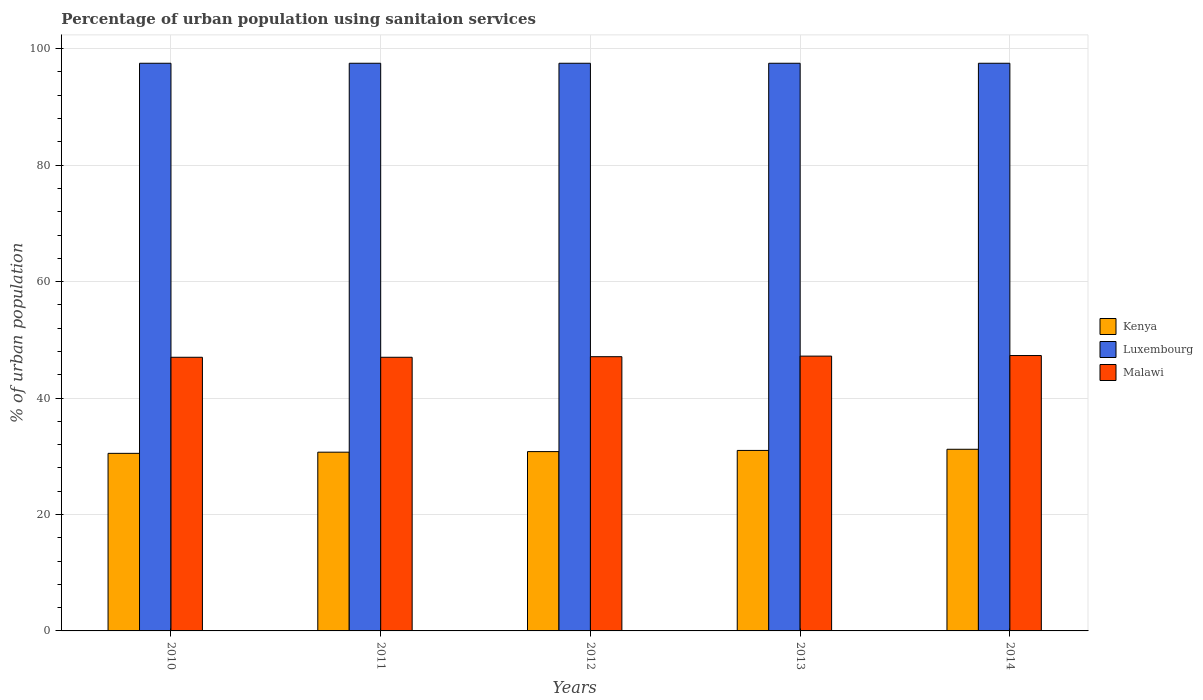How many groups of bars are there?
Ensure brevity in your answer.  5. Are the number of bars on each tick of the X-axis equal?
Ensure brevity in your answer.  Yes. How many bars are there on the 3rd tick from the left?
Keep it short and to the point. 3. What is the percentage of urban population using sanitaion services in Malawi in 2013?
Provide a succinct answer. 47.2. Across all years, what is the maximum percentage of urban population using sanitaion services in Luxembourg?
Your answer should be compact. 97.5. Across all years, what is the minimum percentage of urban population using sanitaion services in Luxembourg?
Keep it short and to the point. 97.5. In which year was the percentage of urban population using sanitaion services in Luxembourg maximum?
Provide a short and direct response. 2010. In which year was the percentage of urban population using sanitaion services in Luxembourg minimum?
Your answer should be very brief. 2010. What is the total percentage of urban population using sanitaion services in Kenya in the graph?
Keep it short and to the point. 154.2. What is the difference between the percentage of urban population using sanitaion services in Luxembourg in 2010 and that in 2013?
Give a very brief answer. 0. What is the difference between the percentage of urban population using sanitaion services in Kenya in 2010 and the percentage of urban population using sanitaion services in Luxembourg in 2013?
Your response must be concise. -67. What is the average percentage of urban population using sanitaion services in Luxembourg per year?
Your answer should be very brief. 97.5. In the year 2014, what is the difference between the percentage of urban population using sanitaion services in Malawi and percentage of urban population using sanitaion services in Luxembourg?
Provide a succinct answer. -50.2. What is the ratio of the percentage of urban population using sanitaion services in Kenya in 2011 to that in 2014?
Make the answer very short. 0.98. Is the percentage of urban population using sanitaion services in Malawi in 2013 less than that in 2014?
Provide a succinct answer. Yes. Is the difference between the percentage of urban population using sanitaion services in Malawi in 2011 and 2014 greater than the difference between the percentage of urban population using sanitaion services in Luxembourg in 2011 and 2014?
Give a very brief answer. No. What is the difference between the highest and the second highest percentage of urban population using sanitaion services in Luxembourg?
Your answer should be very brief. 0. What does the 1st bar from the left in 2011 represents?
Offer a terse response. Kenya. What does the 1st bar from the right in 2012 represents?
Ensure brevity in your answer.  Malawi. Is it the case that in every year, the sum of the percentage of urban population using sanitaion services in Luxembourg and percentage of urban population using sanitaion services in Kenya is greater than the percentage of urban population using sanitaion services in Malawi?
Offer a terse response. Yes. Are all the bars in the graph horizontal?
Provide a short and direct response. No. How many years are there in the graph?
Make the answer very short. 5. Does the graph contain any zero values?
Offer a terse response. No. Does the graph contain grids?
Offer a very short reply. Yes. How many legend labels are there?
Give a very brief answer. 3. How are the legend labels stacked?
Keep it short and to the point. Vertical. What is the title of the graph?
Give a very brief answer. Percentage of urban population using sanitaion services. What is the label or title of the X-axis?
Provide a succinct answer. Years. What is the label or title of the Y-axis?
Keep it short and to the point. % of urban population. What is the % of urban population of Kenya in 2010?
Keep it short and to the point. 30.5. What is the % of urban population of Luxembourg in 2010?
Keep it short and to the point. 97.5. What is the % of urban population in Kenya in 2011?
Give a very brief answer. 30.7. What is the % of urban population of Luxembourg in 2011?
Make the answer very short. 97.5. What is the % of urban population in Kenya in 2012?
Provide a short and direct response. 30.8. What is the % of urban population in Luxembourg in 2012?
Provide a short and direct response. 97.5. What is the % of urban population in Malawi in 2012?
Your response must be concise. 47.1. What is the % of urban population in Kenya in 2013?
Offer a terse response. 31. What is the % of urban population of Luxembourg in 2013?
Your response must be concise. 97.5. What is the % of urban population in Malawi in 2013?
Your response must be concise. 47.2. What is the % of urban population of Kenya in 2014?
Keep it short and to the point. 31.2. What is the % of urban population of Luxembourg in 2014?
Your answer should be very brief. 97.5. What is the % of urban population in Malawi in 2014?
Give a very brief answer. 47.3. Across all years, what is the maximum % of urban population in Kenya?
Offer a very short reply. 31.2. Across all years, what is the maximum % of urban population of Luxembourg?
Make the answer very short. 97.5. Across all years, what is the maximum % of urban population of Malawi?
Keep it short and to the point. 47.3. Across all years, what is the minimum % of urban population in Kenya?
Ensure brevity in your answer.  30.5. Across all years, what is the minimum % of urban population of Luxembourg?
Provide a short and direct response. 97.5. What is the total % of urban population in Kenya in the graph?
Provide a succinct answer. 154.2. What is the total % of urban population of Luxembourg in the graph?
Provide a succinct answer. 487.5. What is the total % of urban population in Malawi in the graph?
Offer a terse response. 235.6. What is the difference between the % of urban population in Kenya in 2010 and that in 2012?
Your response must be concise. -0.3. What is the difference between the % of urban population of Kenya in 2010 and that in 2013?
Offer a terse response. -0.5. What is the difference between the % of urban population of Kenya in 2010 and that in 2014?
Give a very brief answer. -0.7. What is the difference between the % of urban population in Luxembourg in 2010 and that in 2014?
Provide a short and direct response. 0. What is the difference between the % of urban population of Kenya in 2011 and that in 2012?
Make the answer very short. -0.1. What is the difference between the % of urban population of Luxembourg in 2011 and that in 2012?
Your answer should be compact. 0. What is the difference between the % of urban population of Luxembourg in 2011 and that in 2013?
Provide a short and direct response. 0. What is the difference between the % of urban population in Malawi in 2011 and that in 2013?
Make the answer very short. -0.2. What is the difference between the % of urban population in Malawi in 2011 and that in 2014?
Provide a succinct answer. -0.3. What is the difference between the % of urban population of Luxembourg in 2012 and that in 2013?
Offer a terse response. 0. What is the difference between the % of urban population of Malawi in 2012 and that in 2013?
Give a very brief answer. -0.1. What is the difference between the % of urban population of Luxembourg in 2012 and that in 2014?
Offer a terse response. 0. What is the difference between the % of urban population in Kenya in 2013 and that in 2014?
Ensure brevity in your answer.  -0.2. What is the difference between the % of urban population of Malawi in 2013 and that in 2014?
Your answer should be compact. -0.1. What is the difference between the % of urban population of Kenya in 2010 and the % of urban population of Luxembourg in 2011?
Your answer should be very brief. -67. What is the difference between the % of urban population in Kenya in 2010 and the % of urban population in Malawi in 2011?
Offer a very short reply. -16.5. What is the difference between the % of urban population in Luxembourg in 2010 and the % of urban population in Malawi in 2011?
Your answer should be compact. 50.5. What is the difference between the % of urban population of Kenya in 2010 and the % of urban population of Luxembourg in 2012?
Provide a succinct answer. -67. What is the difference between the % of urban population in Kenya in 2010 and the % of urban population in Malawi in 2012?
Offer a very short reply. -16.6. What is the difference between the % of urban population in Luxembourg in 2010 and the % of urban population in Malawi in 2012?
Provide a succinct answer. 50.4. What is the difference between the % of urban population in Kenya in 2010 and the % of urban population in Luxembourg in 2013?
Offer a terse response. -67. What is the difference between the % of urban population of Kenya in 2010 and the % of urban population of Malawi in 2013?
Your answer should be very brief. -16.7. What is the difference between the % of urban population in Luxembourg in 2010 and the % of urban population in Malawi in 2013?
Offer a very short reply. 50.3. What is the difference between the % of urban population of Kenya in 2010 and the % of urban population of Luxembourg in 2014?
Your response must be concise. -67. What is the difference between the % of urban population in Kenya in 2010 and the % of urban population in Malawi in 2014?
Provide a short and direct response. -16.8. What is the difference between the % of urban population of Luxembourg in 2010 and the % of urban population of Malawi in 2014?
Make the answer very short. 50.2. What is the difference between the % of urban population of Kenya in 2011 and the % of urban population of Luxembourg in 2012?
Provide a succinct answer. -66.8. What is the difference between the % of urban population in Kenya in 2011 and the % of urban population in Malawi in 2012?
Keep it short and to the point. -16.4. What is the difference between the % of urban population of Luxembourg in 2011 and the % of urban population of Malawi in 2012?
Your answer should be very brief. 50.4. What is the difference between the % of urban population of Kenya in 2011 and the % of urban population of Luxembourg in 2013?
Make the answer very short. -66.8. What is the difference between the % of urban population of Kenya in 2011 and the % of urban population of Malawi in 2013?
Offer a very short reply. -16.5. What is the difference between the % of urban population in Luxembourg in 2011 and the % of urban population in Malawi in 2013?
Make the answer very short. 50.3. What is the difference between the % of urban population of Kenya in 2011 and the % of urban population of Luxembourg in 2014?
Give a very brief answer. -66.8. What is the difference between the % of urban population in Kenya in 2011 and the % of urban population in Malawi in 2014?
Your answer should be compact. -16.6. What is the difference between the % of urban population of Luxembourg in 2011 and the % of urban population of Malawi in 2014?
Your answer should be compact. 50.2. What is the difference between the % of urban population in Kenya in 2012 and the % of urban population in Luxembourg in 2013?
Provide a succinct answer. -66.7. What is the difference between the % of urban population in Kenya in 2012 and the % of urban population in Malawi in 2013?
Offer a terse response. -16.4. What is the difference between the % of urban population in Luxembourg in 2012 and the % of urban population in Malawi in 2013?
Give a very brief answer. 50.3. What is the difference between the % of urban population of Kenya in 2012 and the % of urban population of Luxembourg in 2014?
Make the answer very short. -66.7. What is the difference between the % of urban population of Kenya in 2012 and the % of urban population of Malawi in 2014?
Give a very brief answer. -16.5. What is the difference between the % of urban population in Luxembourg in 2012 and the % of urban population in Malawi in 2014?
Your response must be concise. 50.2. What is the difference between the % of urban population in Kenya in 2013 and the % of urban population in Luxembourg in 2014?
Provide a succinct answer. -66.5. What is the difference between the % of urban population of Kenya in 2013 and the % of urban population of Malawi in 2014?
Your response must be concise. -16.3. What is the difference between the % of urban population of Luxembourg in 2013 and the % of urban population of Malawi in 2014?
Give a very brief answer. 50.2. What is the average % of urban population in Kenya per year?
Offer a terse response. 30.84. What is the average % of urban population in Luxembourg per year?
Offer a terse response. 97.5. What is the average % of urban population in Malawi per year?
Your response must be concise. 47.12. In the year 2010, what is the difference between the % of urban population in Kenya and % of urban population in Luxembourg?
Give a very brief answer. -67. In the year 2010, what is the difference between the % of urban population in Kenya and % of urban population in Malawi?
Make the answer very short. -16.5. In the year 2010, what is the difference between the % of urban population of Luxembourg and % of urban population of Malawi?
Your answer should be compact. 50.5. In the year 2011, what is the difference between the % of urban population of Kenya and % of urban population of Luxembourg?
Your response must be concise. -66.8. In the year 2011, what is the difference between the % of urban population in Kenya and % of urban population in Malawi?
Provide a succinct answer. -16.3. In the year 2011, what is the difference between the % of urban population of Luxembourg and % of urban population of Malawi?
Your answer should be very brief. 50.5. In the year 2012, what is the difference between the % of urban population in Kenya and % of urban population in Luxembourg?
Make the answer very short. -66.7. In the year 2012, what is the difference between the % of urban population in Kenya and % of urban population in Malawi?
Make the answer very short. -16.3. In the year 2012, what is the difference between the % of urban population in Luxembourg and % of urban population in Malawi?
Your answer should be compact. 50.4. In the year 2013, what is the difference between the % of urban population of Kenya and % of urban population of Luxembourg?
Provide a succinct answer. -66.5. In the year 2013, what is the difference between the % of urban population of Kenya and % of urban population of Malawi?
Give a very brief answer. -16.2. In the year 2013, what is the difference between the % of urban population of Luxembourg and % of urban population of Malawi?
Your answer should be compact. 50.3. In the year 2014, what is the difference between the % of urban population in Kenya and % of urban population in Luxembourg?
Give a very brief answer. -66.3. In the year 2014, what is the difference between the % of urban population of Kenya and % of urban population of Malawi?
Ensure brevity in your answer.  -16.1. In the year 2014, what is the difference between the % of urban population of Luxembourg and % of urban population of Malawi?
Keep it short and to the point. 50.2. What is the ratio of the % of urban population in Malawi in 2010 to that in 2011?
Your answer should be very brief. 1. What is the ratio of the % of urban population of Kenya in 2010 to that in 2012?
Provide a succinct answer. 0.99. What is the ratio of the % of urban population of Malawi in 2010 to that in 2012?
Your response must be concise. 1. What is the ratio of the % of urban population in Kenya in 2010 to that in 2013?
Your answer should be compact. 0.98. What is the ratio of the % of urban population in Malawi in 2010 to that in 2013?
Your answer should be compact. 1. What is the ratio of the % of urban population in Kenya in 2010 to that in 2014?
Provide a succinct answer. 0.98. What is the ratio of the % of urban population of Kenya in 2011 to that in 2012?
Provide a succinct answer. 1. What is the ratio of the % of urban population in Luxembourg in 2011 to that in 2012?
Provide a succinct answer. 1. What is the ratio of the % of urban population of Malawi in 2011 to that in 2012?
Your answer should be compact. 1. What is the ratio of the % of urban population of Kenya in 2011 to that in 2013?
Your answer should be compact. 0.99. What is the ratio of the % of urban population of Malawi in 2011 to that in 2013?
Make the answer very short. 1. What is the ratio of the % of urban population of Luxembourg in 2011 to that in 2014?
Provide a succinct answer. 1. What is the ratio of the % of urban population in Kenya in 2012 to that in 2013?
Provide a succinct answer. 0.99. What is the ratio of the % of urban population of Luxembourg in 2012 to that in 2013?
Give a very brief answer. 1. What is the ratio of the % of urban population in Kenya in 2012 to that in 2014?
Your response must be concise. 0.99. What is the ratio of the % of urban population in Malawi in 2012 to that in 2014?
Offer a very short reply. 1. What is the ratio of the % of urban population of Malawi in 2013 to that in 2014?
Your answer should be compact. 1. What is the difference between the highest and the second highest % of urban population in Kenya?
Keep it short and to the point. 0.2. What is the difference between the highest and the lowest % of urban population in Kenya?
Provide a short and direct response. 0.7. What is the difference between the highest and the lowest % of urban population in Malawi?
Offer a very short reply. 0.3. 